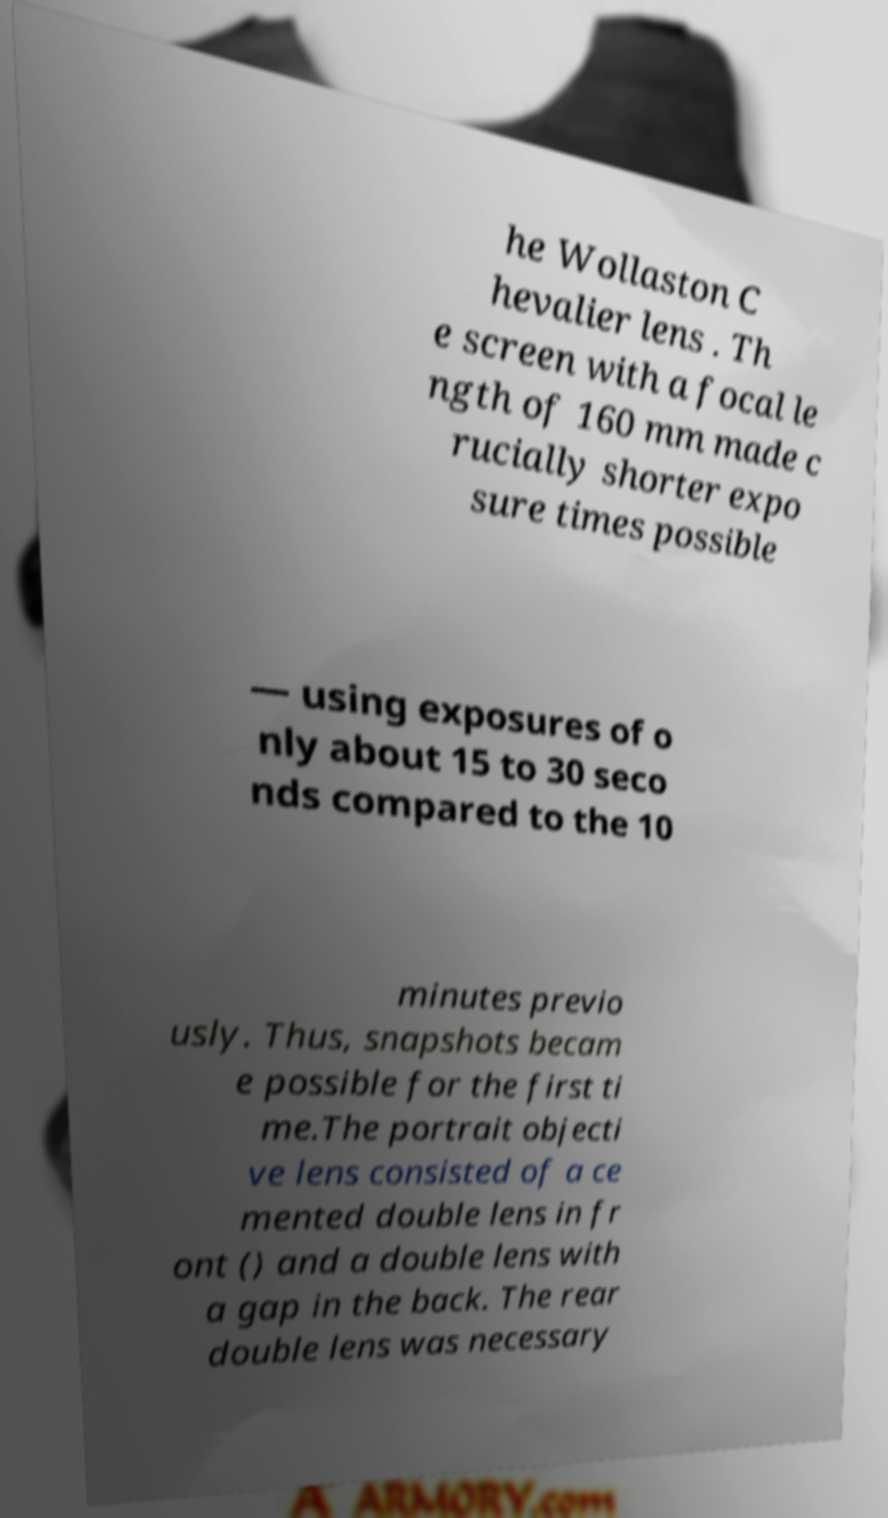Please identify and transcribe the text found in this image. he Wollaston C hevalier lens . Th e screen with a focal le ngth of 160 mm made c rucially shorter expo sure times possible — using exposures of o nly about 15 to 30 seco nds compared to the 10 minutes previo usly. Thus, snapshots becam e possible for the first ti me.The portrait objecti ve lens consisted of a ce mented double lens in fr ont () and a double lens with a gap in the back. The rear double lens was necessary 